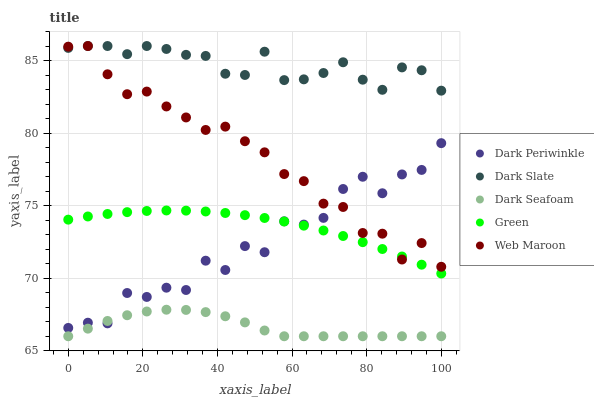Does Dark Seafoam have the minimum area under the curve?
Answer yes or no. Yes. Does Dark Slate have the maximum area under the curve?
Answer yes or no. Yes. Does Green have the minimum area under the curve?
Answer yes or no. No. Does Green have the maximum area under the curve?
Answer yes or no. No. Is Green the smoothest?
Answer yes or no. Yes. Is Dark Periwinkle the roughest?
Answer yes or no. Yes. Is Dark Seafoam the smoothest?
Answer yes or no. No. Is Dark Seafoam the roughest?
Answer yes or no. No. Does Dark Seafoam have the lowest value?
Answer yes or no. Yes. Does Green have the lowest value?
Answer yes or no. No. Does Web Maroon have the highest value?
Answer yes or no. Yes. Does Green have the highest value?
Answer yes or no. No. Is Dark Seafoam less than Web Maroon?
Answer yes or no. Yes. Is Green greater than Dark Seafoam?
Answer yes or no. Yes. Does Dark Periwinkle intersect Dark Seafoam?
Answer yes or no. Yes. Is Dark Periwinkle less than Dark Seafoam?
Answer yes or no. No. Is Dark Periwinkle greater than Dark Seafoam?
Answer yes or no. No. Does Dark Seafoam intersect Web Maroon?
Answer yes or no. No. 